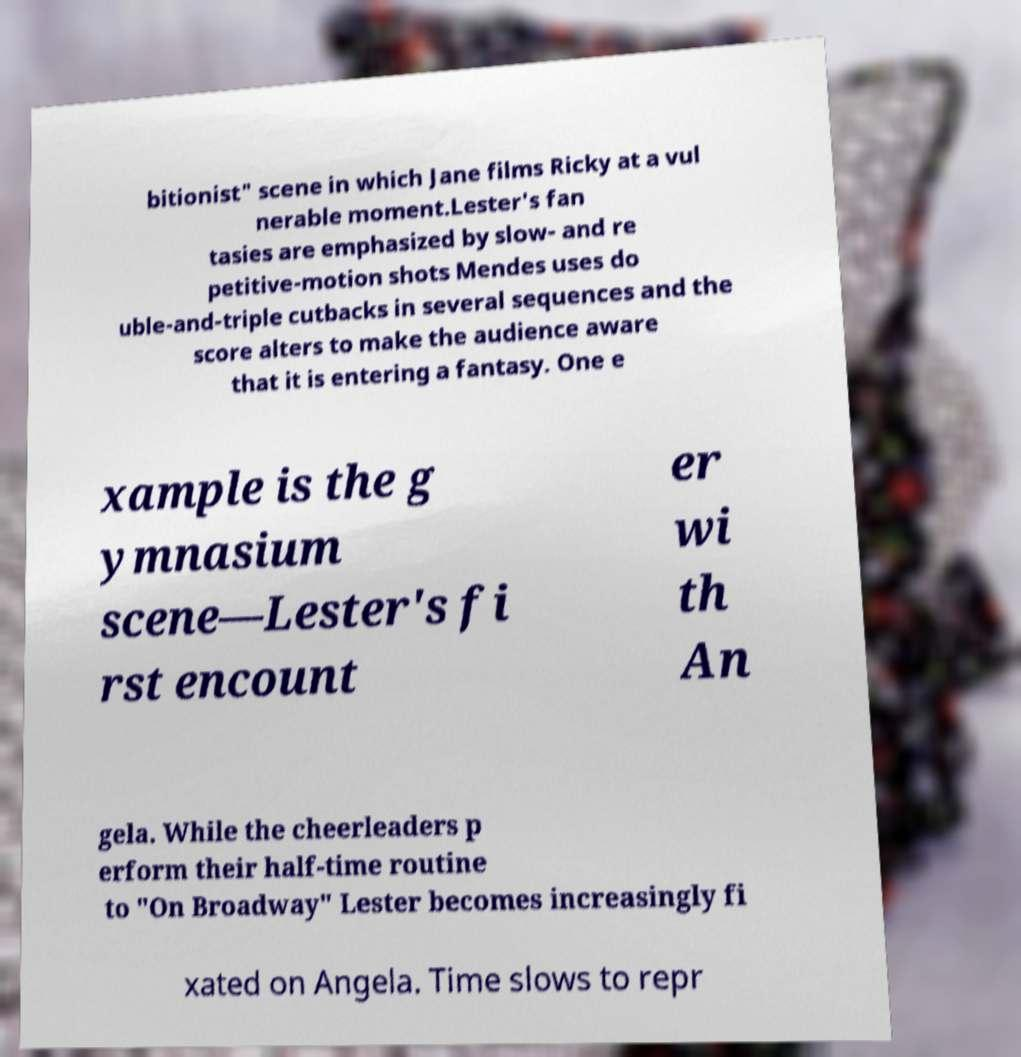There's text embedded in this image that I need extracted. Can you transcribe it verbatim? bitionist" scene in which Jane films Ricky at a vul nerable moment.Lester's fan tasies are emphasized by slow- and re petitive-motion shots Mendes uses do uble-and-triple cutbacks in several sequences and the score alters to make the audience aware that it is entering a fantasy. One e xample is the g ymnasium scene—Lester's fi rst encount er wi th An gela. While the cheerleaders p erform their half-time routine to "On Broadway" Lester becomes increasingly fi xated on Angela. Time slows to repr 